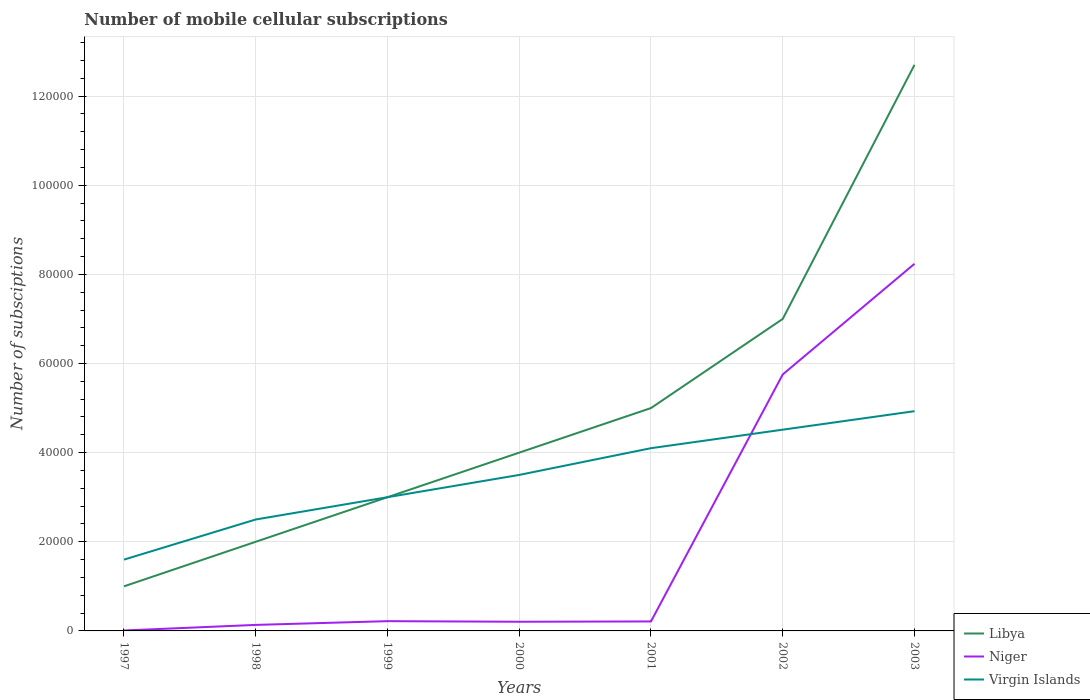Does the line corresponding to Libya intersect with the line corresponding to Virgin Islands?
Offer a terse response. Yes. Is the number of lines equal to the number of legend labels?
Offer a very short reply. Yes. Across all years, what is the maximum number of mobile cellular subscriptions in Libya?
Make the answer very short. 10000. In which year was the number of mobile cellular subscriptions in Virgin Islands maximum?
Your answer should be very brief. 1997. What is the total number of mobile cellular subscriptions in Niger in the graph?
Offer a terse response. -2.48e+04. What is the difference between the highest and the second highest number of mobile cellular subscriptions in Libya?
Your answer should be very brief. 1.17e+05. What is the difference between the highest and the lowest number of mobile cellular subscriptions in Virgin Islands?
Give a very brief answer. 4. Is the number of mobile cellular subscriptions in Niger strictly greater than the number of mobile cellular subscriptions in Libya over the years?
Your answer should be compact. Yes. Does the graph contain grids?
Provide a succinct answer. Yes. Where does the legend appear in the graph?
Keep it short and to the point. Bottom right. How many legend labels are there?
Ensure brevity in your answer.  3. What is the title of the graph?
Your answer should be compact. Number of mobile cellular subscriptions. What is the label or title of the X-axis?
Give a very brief answer. Years. What is the label or title of the Y-axis?
Offer a very short reply. Number of subsciptions. What is the Number of subsciptions in Niger in 1997?
Offer a very short reply. 98. What is the Number of subsciptions of Virgin Islands in 1997?
Make the answer very short. 1.60e+04. What is the Number of subsciptions of Libya in 1998?
Make the answer very short. 2.00e+04. What is the Number of subsciptions in Niger in 1998?
Make the answer very short. 1349. What is the Number of subsciptions of Virgin Islands in 1998?
Offer a very short reply. 2.50e+04. What is the Number of subsciptions in Niger in 1999?
Give a very brief answer. 2192. What is the Number of subsciptions in Niger in 2000?
Your answer should be very brief. 2056. What is the Number of subsciptions of Virgin Islands in 2000?
Offer a terse response. 3.50e+04. What is the Number of subsciptions of Libya in 2001?
Your answer should be compact. 5.00e+04. What is the Number of subsciptions of Niger in 2001?
Ensure brevity in your answer.  2126. What is the Number of subsciptions in Virgin Islands in 2001?
Your answer should be very brief. 4.10e+04. What is the Number of subsciptions of Libya in 2002?
Offer a terse response. 7.00e+04. What is the Number of subsciptions of Niger in 2002?
Offer a very short reply. 5.75e+04. What is the Number of subsciptions of Virgin Islands in 2002?
Your answer should be very brief. 4.52e+04. What is the Number of subsciptions of Libya in 2003?
Your answer should be very brief. 1.27e+05. What is the Number of subsciptions in Niger in 2003?
Offer a very short reply. 8.24e+04. What is the Number of subsciptions of Virgin Islands in 2003?
Your answer should be very brief. 4.93e+04. Across all years, what is the maximum Number of subsciptions in Libya?
Your response must be concise. 1.27e+05. Across all years, what is the maximum Number of subsciptions of Niger?
Offer a terse response. 8.24e+04. Across all years, what is the maximum Number of subsciptions in Virgin Islands?
Give a very brief answer. 4.93e+04. Across all years, what is the minimum Number of subsciptions of Virgin Islands?
Your response must be concise. 1.60e+04. What is the total Number of subsciptions in Libya in the graph?
Provide a short and direct response. 3.47e+05. What is the total Number of subsciptions in Niger in the graph?
Give a very brief answer. 1.48e+05. What is the total Number of subsciptions in Virgin Islands in the graph?
Your response must be concise. 2.41e+05. What is the difference between the Number of subsciptions of Libya in 1997 and that in 1998?
Provide a succinct answer. -10000. What is the difference between the Number of subsciptions of Niger in 1997 and that in 1998?
Your response must be concise. -1251. What is the difference between the Number of subsciptions in Virgin Islands in 1997 and that in 1998?
Your answer should be compact. -9000. What is the difference between the Number of subsciptions in Niger in 1997 and that in 1999?
Offer a very short reply. -2094. What is the difference between the Number of subsciptions of Virgin Islands in 1997 and that in 1999?
Offer a very short reply. -1.40e+04. What is the difference between the Number of subsciptions of Libya in 1997 and that in 2000?
Offer a very short reply. -3.00e+04. What is the difference between the Number of subsciptions in Niger in 1997 and that in 2000?
Give a very brief answer. -1958. What is the difference between the Number of subsciptions of Virgin Islands in 1997 and that in 2000?
Provide a short and direct response. -1.90e+04. What is the difference between the Number of subsciptions in Niger in 1997 and that in 2001?
Provide a short and direct response. -2028. What is the difference between the Number of subsciptions of Virgin Islands in 1997 and that in 2001?
Your response must be concise. -2.50e+04. What is the difference between the Number of subsciptions in Niger in 1997 and that in 2002?
Your response must be concise. -5.74e+04. What is the difference between the Number of subsciptions of Virgin Islands in 1997 and that in 2002?
Your answer should be very brief. -2.92e+04. What is the difference between the Number of subsciptions in Libya in 1997 and that in 2003?
Ensure brevity in your answer.  -1.17e+05. What is the difference between the Number of subsciptions of Niger in 1997 and that in 2003?
Your answer should be very brief. -8.23e+04. What is the difference between the Number of subsciptions in Virgin Islands in 1997 and that in 2003?
Offer a very short reply. -3.33e+04. What is the difference between the Number of subsciptions in Libya in 1998 and that in 1999?
Make the answer very short. -10000. What is the difference between the Number of subsciptions in Niger in 1998 and that in 1999?
Offer a very short reply. -843. What is the difference between the Number of subsciptions in Virgin Islands in 1998 and that in 1999?
Your response must be concise. -5000. What is the difference between the Number of subsciptions in Libya in 1998 and that in 2000?
Keep it short and to the point. -2.00e+04. What is the difference between the Number of subsciptions in Niger in 1998 and that in 2000?
Make the answer very short. -707. What is the difference between the Number of subsciptions in Libya in 1998 and that in 2001?
Keep it short and to the point. -3.00e+04. What is the difference between the Number of subsciptions of Niger in 1998 and that in 2001?
Make the answer very short. -777. What is the difference between the Number of subsciptions in Virgin Islands in 1998 and that in 2001?
Make the answer very short. -1.60e+04. What is the difference between the Number of subsciptions of Libya in 1998 and that in 2002?
Your answer should be compact. -5.00e+04. What is the difference between the Number of subsciptions in Niger in 1998 and that in 2002?
Offer a very short reply. -5.62e+04. What is the difference between the Number of subsciptions of Virgin Islands in 1998 and that in 2002?
Offer a terse response. -2.02e+04. What is the difference between the Number of subsciptions of Libya in 1998 and that in 2003?
Offer a very short reply. -1.07e+05. What is the difference between the Number of subsciptions of Niger in 1998 and that in 2003?
Keep it short and to the point. -8.10e+04. What is the difference between the Number of subsciptions of Virgin Islands in 1998 and that in 2003?
Make the answer very short. -2.43e+04. What is the difference between the Number of subsciptions in Libya in 1999 and that in 2000?
Offer a very short reply. -10000. What is the difference between the Number of subsciptions in Niger in 1999 and that in 2000?
Offer a terse response. 136. What is the difference between the Number of subsciptions of Virgin Islands in 1999 and that in 2000?
Your response must be concise. -5000. What is the difference between the Number of subsciptions of Virgin Islands in 1999 and that in 2001?
Offer a terse response. -1.10e+04. What is the difference between the Number of subsciptions of Niger in 1999 and that in 2002?
Your answer should be compact. -5.53e+04. What is the difference between the Number of subsciptions in Virgin Islands in 1999 and that in 2002?
Your response must be concise. -1.52e+04. What is the difference between the Number of subsciptions in Libya in 1999 and that in 2003?
Offer a very short reply. -9.70e+04. What is the difference between the Number of subsciptions in Niger in 1999 and that in 2003?
Make the answer very short. -8.02e+04. What is the difference between the Number of subsciptions of Virgin Islands in 1999 and that in 2003?
Offer a terse response. -1.93e+04. What is the difference between the Number of subsciptions of Niger in 2000 and that in 2001?
Your answer should be compact. -70. What is the difference between the Number of subsciptions of Virgin Islands in 2000 and that in 2001?
Your answer should be very brief. -6000. What is the difference between the Number of subsciptions of Niger in 2000 and that in 2002?
Your response must be concise. -5.55e+04. What is the difference between the Number of subsciptions in Virgin Islands in 2000 and that in 2002?
Offer a very short reply. -1.02e+04. What is the difference between the Number of subsciptions in Libya in 2000 and that in 2003?
Keep it short and to the point. -8.70e+04. What is the difference between the Number of subsciptions of Niger in 2000 and that in 2003?
Make the answer very short. -8.03e+04. What is the difference between the Number of subsciptions of Virgin Islands in 2000 and that in 2003?
Offer a terse response. -1.43e+04. What is the difference between the Number of subsciptions in Libya in 2001 and that in 2002?
Offer a terse response. -2.00e+04. What is the difference between the Number of subsciptions in Niger in 2001 and that in 2002?
Keep it short and to the point. -5.54e+04. What is the difference between the Number of subsciptions of Virgin Islands in 2001 and that in 2002?
Make the answer very short. -4150. What is the difference between the Number of subsciptions in Libya in 2001 and that in 2003?
Your answer should be compact. -7.70e+04. What is the difference between the Number of subsciptions in Niger in 2001 and that in 2003?
Your answer should be compact. -8.02e+04. What is the difference between the Number of subsciptions in Virgin Islands in 2001 and that in 2003?
Your answer should be very brief. -8300. What is the difference between the Number of subsciptions in Libya in 2002 and that in 2003?
Your answer should be very brief. -5.70e+04. What is the difference between the Number of subsciptions in Niger in 2002 and that in 2003?
Make the answer very short. -2.48e+04. What is the difference between the Number of subsciptions of Virgin Islands in 2002 and that in 2003?
Your answer should be compact. -4150. What is the difference between the Number of subsciptions in Libya in 1997 and the Number of subsciptions in Niger in 1998?
Offer a very short reply. 8651. What is the difference between the Number of subsciptions in Libya in 1997 and the Number of subsciptions in Virgin Islands in 1998?
Make the answer very short. -1.50e+04. What is the difference between the Number of subsciptions of Niger in 1997 and the Number of subsciptions of Virgin Islands in 1998?
Make the answer very short. -2.49e+04. What is the difference between the Number of subsciptions of Libya in 1997 and the Number of subsciptions of Niger in 1999?
Your answer should be compact. 7808. What is the difference between the Number of subsciptions in Libya in 1997 and the Number of subsciptions in Virgin Islands in 1999?
Offer a terse response. -2.00e+04. What is the difference between the Number of subsciptions in Niger in 1997 and the Number of subsciptions in Virgin Islands in 1999?
Your response must be concise. -2.99e+04. What is the difference between the Number of subsciptions of Libya in 1997 and the Number of subsciptions of Niger in 2000?
Offer a very short reply. 7944. What is the difference between the Number of subsciptions in Libya in 1997 and the Number of subsciptions in Virgin Islands in 2000?
Offer a very short reply. -2.50e+04. What is the difference between the Number of subsciptions of Niger in 1997 and the Number of subsciptions of Virgin Islands in 2000?
Ensure brevity in your answer.  -3.49e+04. What is the difference between the Number of subsciptions of Libya in 1997 and the Number of subsciptions of Niger in 2001?
Offer a terse response. 7874. What is the difference between the Number of subsciptions of Libya in 1997 and the Number of subsciptions of Virgin Islands in 2001?
Provide a short and direct response. -3.10e+04. What is the difference between the Number of subsciptions of Niger in 1997 and the Number of subsciptions of Virgin Islands in 2001?
Provide a short and direct response. -4.09e+04. What is the difference between the Number of subsciptions in Libya in 1997 and the Number of subsciptions in Niger in 2002?
Your answer should be compact. -4.75e+04. What is the difference between the Number of subsciptions in Libya in 1997 and the Number of subsciptions in Virgin Islands in 2002?
Provide a succinct answer. -3.52e+04. What is the difference between the Number of subsciptions in Niger in 1997 and the Number of subsciptions in Virgin Islands in 2002?
Your answer should be compact. -4.51e+04. What is the difference between the Number of subsciptions in Libya in 1997 and the Number of subsciptions in Niger in 2003?
Give a very brief answer. -7.24e+04. What is the difference between the Number of subsciptions in Libya in 1997 and the Number of subsciptions in Virgin Islands in 2003?
Give a very brief answer. -3.93e+04. What is the difference between the Number of subsciptions in Niger in 1997 and the Number of subsciptions in Virgin Islands in 2003?
Keep it short and to the point. -4.92e+04. What is the difference between the Number of subsciptions in Libya in 1998 and the Number of subsciptions in Niger in 1999?
Your answer should be very brief. 1.78e+04. What is the difference between the Number of subsciptions of Libya in 1998 and the Number of subsciptions of Virgin Islands in 1999?
Offer a very short reply. -10000. What is the difference between the Number of subsciptions in Niger in 1998 and the Number of subsciptions in Virgin Islands in 1999?
Offer a terse response. -2.87e+04. What is the difference between the Number of subsciptions of Libya in 1998 and the Number of subsciptions of Niger in 2000?
Your response must be concise. 1.79e+04. What is the difference between the Number of subsciptions of Libya in 1998 and the Number of subsciptions of Virgin Islands in 2000?
Make the answer very short. -1.50e+04. What is the difference between the Number of subsciptions of Niger in 1998 and the Number of subsciptions of Virgin Islands in 2000?
Offer a terse response. -3.37e+04. What is the difference between the Number of subsciptions in Libya in 1998 and the Number of subsciptions in Niger in 2001?
Keep it short and to the point. 1.79e+04. What is the difference between the Number of subsciptions of Libya in 1998 and the Number of subsciptions of Virgin Islands in 2001?
Ensure brevity in your answer.  -2.10e+04. What is the difference between the Number of subsciptions in Niger in 1998 and the Number of subsciptions in Virgin Islands in 2001?
Give a very brief answer. -3.97e+04. What is the difference between the Number of subsciptions of Libya in 1998 and the Number of subsciptions of Niger in 2002?
Give a very brief answer. -3.75e+04. What is the difference between the Number of subsciptions of Libya in 1998 and the Number of subsciptions of Virgin Islands in 2002?
Offer a terse response. -2.52e+04. What is the difference between the Number of subsciptions in Niger in 1998 and the Number of subsciptions in Virgin Islands in 2002?
Provide a succinct answer. -4.38e+04. What is the difference between the Number of subsciptions of Libya in 1998 and the Number of subsciptions of Niger in 2003?
Ensure brevity in your answer.  -6.24e+04. What is the difference between the Number of subsciptions of Libya in 1998 and the Number of subsciptions of Virgin Islands in 2003?
Offer a very short reply. -2.93e+04. What is the difference between the Number of subsciptions of Niger in 1998 and the Number of subsciptions of Virgin Islands in 2003?
Offer a very short reply. -4.80e+04. What is the difference between the Number of subsciptions of Libya in 1999 and the Number of subsciptions of Niger in 2000?
Your answer should be compact. 2.79e+04. What is the difference between the Number of subsciptions in Libya in 1999 and the Number of subsciptions in Virgin Islands in 2000?
Ensure brevity in your answer.  -5000. What is the difference between the Number of subsciptions of Niger in 1999 and the Number of subsciptions of Virgin Islands in 2000?
Offer a very short reply. -3.28e+04. What is the difference between the Number of subsciptions of Libya in 1999 and the Number of subsciptions of Niger in 2001?
Provide a short and direct response. 2.79e+04. What is the difference between the Number of subsciptions in Libya in 1999 and the Number of subsciptions in Virgin Islands in 2001?
Offer a terse response. -1.10e+04. What is the difference between the Number of subsciptions in Niger in 1999 and the Number of subsciptions in Virgin Islands in 2001?
Your answer should be compact. -3.88e+04. What is the difference between the Number of subsciptions of Libya in 1999 and the Number of subsciptions of Niger in 2002?
Give a very brief answer. -2.75e+04. What is the difference between the Number of subsciptions of Libya in 1999 and the Number of subsciptions of Virgin Islands in 2002?
Offer a very short reply. -1.52e+04. What is the difference between the Number of subsciptions in Niger in 1999 and the Number of subsciptions in Virgin Islands in 2002?
Your answer should be very brief. -4.30e+04. What is the difference between the Number of subsciptions in Libya in 1999 and the Number of subsciptions in Niger in 2003?
Your answer should be very brief. -5.24e+04. What is the difference between the Number of subsciptions in Libya in 1999 and the Number of subsciptions in Virgin Islands in 2003?
Keep it short and to the point. -1.93e+04. What is the difference between the Number of subsciptions in Niger in 1999 and the Number of subsciptions in Virgin Islands in 2003?
Provide a short and direct response. -4.71e+04. What is the difference between the Number of subsciptions in Libya in 2000 and the Number of subsciptions in Niger in 2001?
Give a very brief answer. 3.79e+04. What is the difference between the Number of subsciptions of Libya in 2000 and the Number of subsciptions of Virgin Islands in 2001?
Provide a short and direct response. -1000. What is the difference between the Number of subsciptions of Niger in 2000 and the Number of subsciptions of Virgin Islands in 2001?
Offer a very short reply. -3.89e+04. What is the difference between the Number of subsciptions of Libya in 2000 and the Number of subsciptions of Niger in 2002?
Offer a terse response. -1.75e+04. What is the difference between the Number of subsciptions of Libya in 2000 and the Number of subsciptions of Virgin Islands in 2002?
Offer a terse response. -5150. What is the difference between the Number of subsciptions of Niger in 2000 and the Number of subsciptions of Virgin Islands in 2002?
Keep it short and to the point. -4.31e+04. What is the difference between the Number of subsciptions of Libya in 2000 and the Number of subsciptions of Niger in 2003?
Offer a very short reply. -4.24e+04. What is the difference between the Number of subsciptions in Libya in 2000 and the Number of subsciptions in Virgin Islands in 2003?
Offer a terse response. -9300. What is the difference between the Number of subsciptions in Niger in 2000 and the Number of subsciptions in Virgin Islands in 2003?
Offer a terse response. -4.72e+04. What is the difference between the Number of subsciptions of Libya in 2001 and the Number of subsciptions of Niger in 2002?
Your response must be concise. -7541. What is the difference between the Number of subsciptions in Libya in 2001 and the Number of subsciptions in Virgin Islands in 2002?
Keep it short and to the point. 4850. What is the difference between the Number of subsciptions in Niger in 2001 and the Number of subsciptions in Virgin Islands in 2002?
Give a very brief answer. -4.30e+04. What is the difference between the Number of subsciptions of Libya in 2001 and the Number of subsciptions of Niger in 2003?
Provide a succinct answer. -3.24e+04. What is the difference between the Number of subsciptions in Libya in 2001 and the Number of subsciptions in Virgin Islands in 2003?
Ensure brevity in your answer.  700. What is the difference between the Number of subsciptions in Niger in 2001 and the Number of subsciptions in Virgin Islands in 2003?
Your answer should be very brief. -4.72e+04. What is the difference between the Number of subsciptions in Libya in 2002 and the Number of subsciptions in Niger in 2003?
Provide a short and direct response. -1.24e+04. What is the difference between the Number of subsciptions in Libya in 2002 and the Number of subsciptions in Virgin Islands in 2003?
Your answer should be very brief. 2.07e+04. What is the difference between the Number of subsciptions in Niger in 2002 and the Number of subsciptions in Virgin Islands in 2003?
Ensure brevity in your answer.  8241. What is the average Number of subsciptions in Libya per year?
Your answer should be compact. 4.96e+04. What is the average Number of subsciptions of Niger per year?
Your answer should be compact. 2.11e+04. What is the average Number of subsciptions of Virgin Islands per year?
Keep it short and to the point. 3.45e+04. In the year 1997, what is the difference between the Number of subsciptions in Libya and Number of subsciptions in Niger?
Your response must be concise. 9902. In the year 1997, what is the difference between the Number of subsciptions in Libya and Number of subsciptions in Virgin Islands?
Offer a very short reply. -6000. In the year 1997, what is the difference between the Number of subsciptions in Niger and Number of subsciptions in Virgin Islands?
Give a very brief answer. -1.59e+04. In the year 1998, what is the difference between the Number of subsciptions in Libya and Number of subsciptions in Niger?
Your response must be concise. 1.87e+04. In the year 1998, what is the difference between the Number of subsciptions in Libya and Number of subsciptions in Virgin Islands?
Make the answer very short. -5000. In the year 1998, what is the difference between the Number of subsciptions of Niger and Number of subsciptions of Virgin Islands?
Offer a very short reply. -2.37e+04. In the year 1999, what is the difference between the Number of subsciptions of Libya and Number of subsciptions of Niger?
Provide a short and direct response. 2.78e+04. In the year 1999, what is the difference between the Number of subsciptions of Niger and Number of subsciptions of Virgin Islands?
Give a very brief answer. -2.78e+04. In the year 2000, what is the difference between the Number of subsciptions of Libya and Number of subsciptions of Niger?
Your answer should be compact. 3.79e+04. In the year 2000, what is the difference between the Number of subsciptions of Niger and Number of subsciptions of Virgin Islands?
Offer a terse response. -3.29e+04. In the year 2001, what is the difference between the Number of subsciptions of Libya and Number of subsciptions of Niger?
Keep it short and to the point. 4.79e+04. In the year 2001, what is the difference between the Number of subsciptions of Libya and Number of subsciptions of Virgin Islands?
Provide a short and direct response. 9000. In the year 2001, what is the difference between the Number of subsciptions in Niger and Number of subsciptions in Virgin Islands?
Offer a very short reply. -3.89e+04. In the year 2002, what is the difference between the Number of subsciptions in Libya and Number of subsciptions in Niger?
Make the answer very short. 1.25e+04. In the year 2002, what is the difference between the Number of subsciptions of Libya and Number of subsciptions of Virgin Islands?
Your answer should be compact. 2.48e+04. In the year 2002, what is the difference between the Number of subsciptions in Niger and Number of subsciptions in Virgin Islands?
Your answer should be compact. 1.24e+04. In the year 2003, what is the difference between the Number of subsciptions of Libya and Number of subsciptions of Niger?
Your response must be concise. 4.46e+04. In the year 2003, what is the difference between the Number of subsciptions in Libya and Number of subsciptions in Virgin Islands?
Provide a succinct answer. 7.77e+04. In the year 2003, what is the difference between the Number of subsciptions in Niger and Number of subsciptions in Virgin Islands?
Your answer should be very brief. 3.31e+04. What is the ratio of the Number of subsciptions in Niger in 1997 to that in 1998?
Provide a short and direct response. 0.07. What is the ratio of the Number of subsciptions of Virgin Islands in 1997 to that in 1998?
Keep it short and to the point. 0.64. What is the ratio of the Number of subsciptions of Niger in 1997 to that in 1999?
Offer a very short reply. 0.04. What is the ratio of the Number of subsciptions in Virgin Islands in 1997 to that in 1999?
Give a very brief answer. 0.53. What is the ratio of the Number of subsciptions of Niger in 1997 to that in 2000?
Provide a succinct answer. 0.05. What is the ratio of the Number of subsciptions in Virgin Islands in 1997 to that in 2000?
Make the answer very short. 0.46. What is the ratio of the Number of subsciptions in Libya in 1997 to that in 2001?
Your answer should be compact. 0.2. What is the ratio of the Number of subsciptions in Niger in 1997 to that in 2001?
Ensure brevity in your answer.  0.05. What is the ratio of the Number of subsciptions of Virgin Islands in 1997 to that in 2001?
Make the answer very short. 0.39. What is the ratio of the Number of subsciptions of Libya in 1997 to that in 2002?
Provide a succinct answer. 0.14. What is the ratio of the Number of subsciptions of Niger in 1997 to that in 2002?
Your answer should be very brief. 0. What is the ratio of the Number of subsciptions of Virgin Islands in 1997 to that in 2002?
Offer a terse response. 0.35. What is the ratio of the Number of subsciptions in Libya in 1997 to that in 2003?
Give a very brief answer. 0.08. What is the ratio of the Number of subsciptions in Niger in 1997 to that in 2003?
Provide a succinct answer. 0. What is the ratio of the Number of subsciptions of Virgin Islands in 1997 to that in 2003?
Provide a succinct answer. 0.32. What is the ratio of the Number of subsciptions in Niger in 1998 to that in 1999?
Offer a very short reply. 0.62. What is the ratio of the Number of subsciptions in Virgin Islands in 1998 to that in 1999?
Keep it short and to the point. 0.83. What is the ratio of the Number of subsciptions of Niger in 1998 to that in 2000?
Make the answer very short. 0.66. What is the ratio of the Number of subsciptions of Virgin Islands in 1998 to that in 2000?
Your response must be concise. 0.71. What is the ratio of the Number of subsciptions in Niger in 1998 to that in 2001?
Offer a very short reply. 0.63. What is the ratio of the Number of subsciptions in Virgin Islands in 1998 to that in 2001?
Provide a succinct answer. 0.61. What is the ratio of the Number of subsciptions of Libya in 1998 to that in 2002?
Give a very brief answer. 0.29. What is the ratio of the Number of subsciptions of Niger in 1998 to that in 2002?
Your answer should be very brief. 0.02. What is the ratio of the Number of subsciptions of Virgin Islands in 1998 to that in 2002?
Your answer should be compact. 0.55. What is the ratio of the Number of subsciptions of Libya in 1998 to that in 2003?
Make the answer very short. 0.16. What is the ratio of the Number of subsciptions in Niger in 1998 to that in 2003?
Your answer should be very brief. 0.02. What is the ratio of the Number of subsciptions of Virgin Islands in 1998 to that in 2003?
Provide a succinct answer. 0.51. What is the ratio of the Number of subsciptions of Niger in 1999 to that in 2000?
Your response must be concise. 1.07. What is the ratio of the Number of subsciptions of Virgin Islands in 1999 to that in 2000?
Keep it short and to the point. 0.86. What is the ratio of the Number of subsciptions in Niger in 1999 to that in 2001?
Ensure brevity in your answer.  1.03. What is the ratio of the Number of subsciptions in Virgin Islands in 1999 to that in 2001?
Your answer should be very brief. 0.73. What is the ratio of the Number of subsciptions in Libya in 1999 to that in 2002?
Offer a terse response. 0.43. What is the ratio of the Number of subsciptions in Niger in 1999 to that in 2002?
Your answer should be compact. 0.04. What is the ratio of the Number of subsciptions in Virgin Islands in 1999 to that in 2002?
Keep it short and to the point. 0.66. What is the ratio of the Number of subsciptions of Libya in 1999 to that in 2003?
Make the answer very short. 0.24. What is the ratio of the Number of subsciptions in Niger in 1999 to that in 2003?
Ensure brevity in your answer.  0.03. What is the ratio of the Number of subsciptions in Virgin Islands in 1999 to that in 2003?
Provide a short and direct response. 0.61. What is the ratio of the Number of subsciptions of Niger in 2000 to that in 2001?
Offer a very short reply. 0.97. What is the ratio of the Number of subsciptions in Virgin Islands in 2000 to that in 2001?
Your response must be concise. 0.85. What is the ratio of the Number of subsciptions of Libya in 2000 to that in 2002?
Keep it short and to the point. 0.57. What is the ratio of the Number of subsciptions of Niger in 2000 to that in 2002?
Your answer should be compact. 0.04. What is the ratio of the Number of subsciptions in Virgin Islands in 2000 to that in 2002?
Ensure brevity in your answer.  0.78. What is the ratio of the Number of subsciptions of Libya in 2000 to that in 2003?
Keep it short and to the point. 0.32. What is the ratio of the Number of subsciptions in Niger in 2000 to that in 2003?
Your answer should be very brief. 0.03. What is the ratio of the Number of subsciptions of Virgin Islands in 2000 to that in 2003?
Provide a short and direct response. 0.71. What is the ratio of the Number of subsciptions in Niger in 2001 to that in 2002?
Keep it short and to the point. 0.04. What is the ratio of the Number of subsciptions of Virgin Islands in 2001 to that in 2002?
Provide a short and direct response. 0.91. What is the ratio of the Number of subsciptions in Libya in 2001 to that in 2003?
Your response must be concise. 0.39. What is the ratio of the Number of subsciptions of Niger in 2001 to that in 2003?
Your response must be concise. 0.03. What is the ratio of the Number of subsciptions in Virgin Islands in 2001 to that in 2003?
Offer a very short reply. 0.83. What is the ratio of the Number of subsciptions of Libya in 2002 to that in 2003?
Keep it short and to the point. 0.55. What is the ratio of the Number of subsciptions of Niger in 2002 to that in 2003?
Offer a very short reply. 0.7. What is the ratio of the Number of subsciptions in Virgin Islands in 2002 to that in 2003?
Ensure brevity in your answer.  0.92. What is the difference between the highest and the second highest Number of subsciptions of Libya?
Keep it short and to the point. 5.70e+04. What is the difference between the highest and the second highest Number of subsciptions in Niger?
Offer a terse response. 2.48e+04. What is the difference between the highest and the second highest Number of subsciptions of Virgin Islands?
Provide a succinct answer. 4150. What is the difference between the highest and the lowest Number of subsciptions in Libya?
Offer a very short reply. 1.17e+05. What is the difference between the highest and the lowest Number of subsciptions of Niger?
Provide a succinct answer. 8.23e+04. What is the difference between the highest and the lowest Number of subsciptions in Virgin Islands?
Make the answer very short. 3.33e+04. 